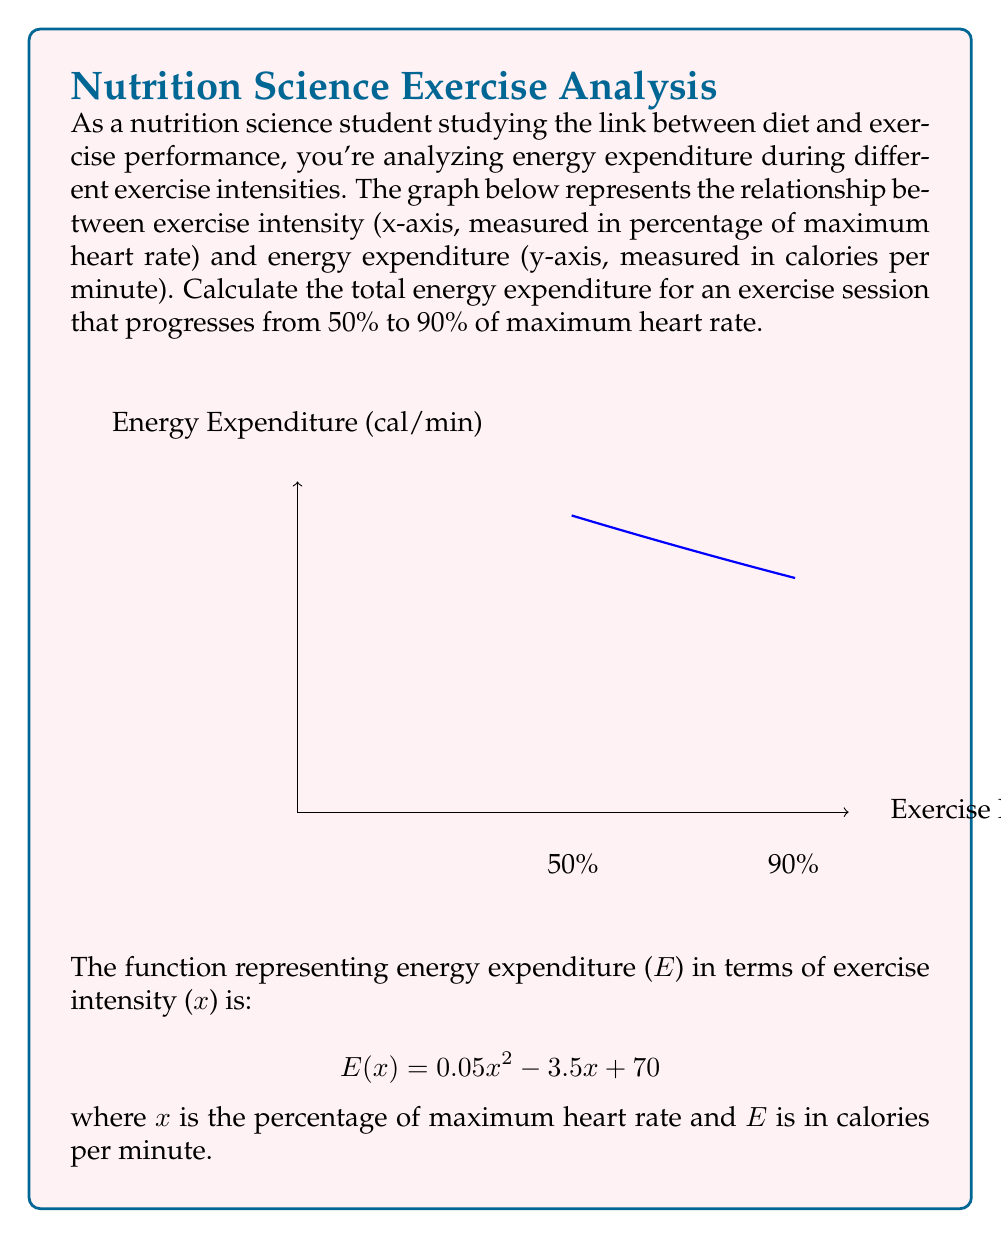Give your solution to this math problem. To calculate the total energy expenditure, we need to find the area under the curve from x = 50 to x = 90. This can be done using definite integration.

Step 1: Set up the definite integral
$$ \int_{50}^{90} (0.05x^2 - 3.5x + 70) dx $$

Step 2: Integrate the function
$$ \left[ \frac{0.05x^3}{3} - \frac{3.5x^2}{2} + 70x \right]_{50}^{90} $$

Step 3: Evaluate the integral at the upper and lower bounds
Upper bound (x = 90):
$$ \frac{0.05(90^3)}{3} - \frac{3.5(90^2)}{2} + 70(90) = 13500 - 14175 + 6300 = 5625 $$

Lower bound (x = 50):
$$ \frac{0.05(50^3)}{3} - \frac{3.5(50^2)}{2} + 70(50) = 2083.33 - 4375 + 3500 = 1208.33 $$

Step 4: Subtract the lower bound from the upper bound
$$ 5625 - 1208.33 = 4416.67 $$

Therefore, the total energy expenditure during this exercise session is approximately 4416.67 calories.
Answer: 4416.67 calories 